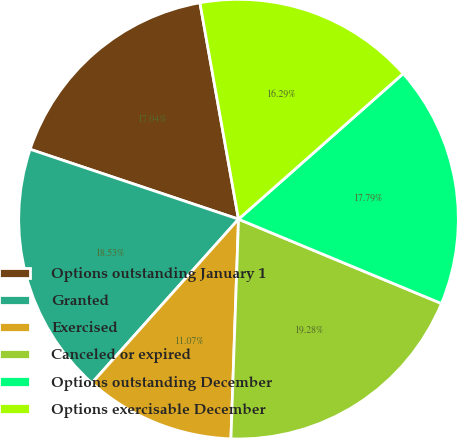Convert chart. <chart><loc_0><loc_0><loc_500><loc_500><pie_chart><fcel>Options outstanding January 1<fcel>Granted<fcel>Exercised<fcel>Canceled or expired<fcel>Options outstanding December<fcel>Options exercisable December<nl><fcel>17.04%<fcel>18.53%<fcel>11.07%<fcel>19.28%<fcel>17.79%<fcel>16.29%<nl></chart> 